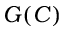Convert formula to latex. <formula><loc_0><loc_0><loc_500><loc_500>G ( C )</formula> 